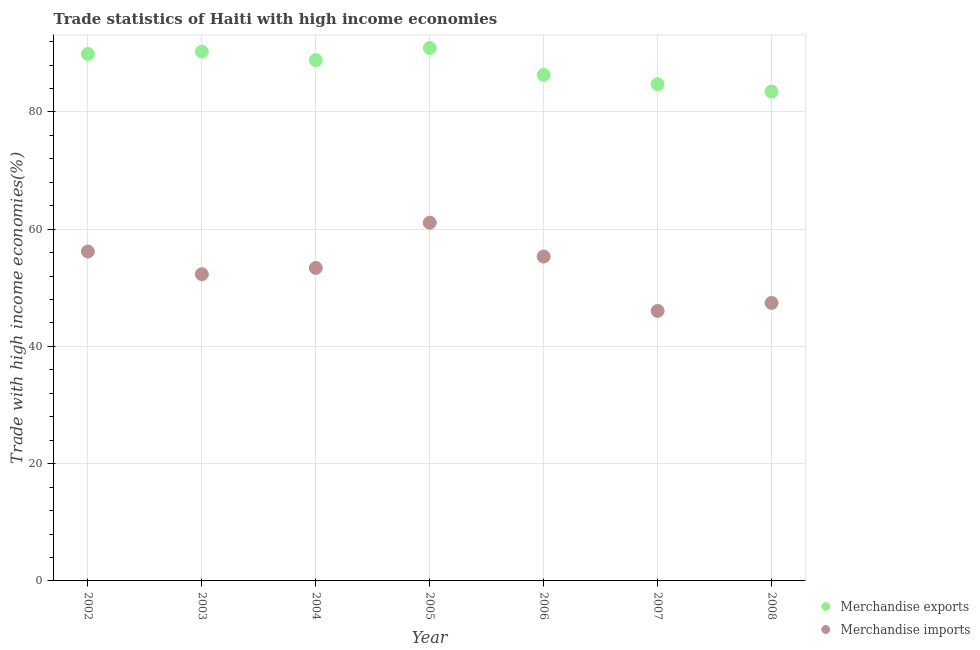Is the number of dotlines equal to the number of legend labels?
Offer a very short reply. Yes. What is the merchandise imports in 2003?
Provide a succinct answer. 52.32. Across all years, what is the maximum merchandise exports?
Offer a very short reply. 90.91. Across all years, what is the minimum merchandise exports?
Provide a short and direct response. 83.47. In which year was the merchandise exports maximum?
Provide a short and direct response. 2005. In which year was the merchandise exports minimum?
Offer a terse response. 2008. What is the total merchandise imports in the graph?
Keep it short and to the point. 371.85. What is the difference between the merchandise imports in 2003 and that in 2008?
Make the answer very short. 4.9. What is the difference between the merchandise imports in 2006 and the merchandise exports in 2002?
Your response must be concise. -34.56. What is the average merchandise exports per year?
Provide a succinct answer. 87.79. In the year 2003, what is the difference between the merchandise imports and merchandise exports?
Provide a short and direct response. -37.97. In how many years, is the merchandise imports greater than 64 %?
Provide a short and direct response. 0. What is the ratio of the merchandise imports in 2002 to that in 2007?
Provide a succinct answer. 1.22. What is the difference between the highest and the second highest merchandise exports?
Keep it short and to the point. 0.61. What is the difference between the highest and the lowest merchandise exports?
Keep it short and to the point. 7.44. Is the sum of the merchandise imports in 2002 and 2004 greater than the maximum merchandise exports across all years?
Ensure brevity in your answer.  Yes. Does the merchandise exports monotonically increase over the years?
Make the answer very short. No. Is the merchandise exports strictly less than the merchandise imports over the years?
Offer a very short reply. No. What is the difference between two consecutive major ticks on the Y-axis?
Offer a terse response. 20. What is the title of the graph?
Your response must be concise. Trade statistics of Haiti with high income economies. What is the label or title of the X-axis?
Give a very brief answer. Year. What is the label or title of the Y-axis?
Give a very brief answer. Trade with high income economies(%). What is the Trade with high income economies(%) of Merchandise exports in 2002?
Ensure brevity in your answer.  89.89. What is the Trade with high income economies(%) of Merchandise imports in 2002?
Your answer should be very brief. 56.19. What is the Trade with high income economies(%) in Merchandise exports in 2003?
Your answer should be compact. 90.3. What is the Trade with high income economies(%) of Merchandise imports in 2003?
Keep it short and to the point. 52.32. What is the Trade with high income economies(%) of Merchandise exports in 2004?
Your response must be concise. 88.85. What is the Trade with high income economies(%) of Merchandise imports in 2004?
Give a very brief answer. 53.39. What is the Trade with high income economies(%) in Merchandise exports in 2005?
Offer a terse response. 90.91. What is the Trade with high income economies(%) of Merchandise imports in 2005?
Offer a very short reply. 61.12. What is the Trade with high income economies(%) in Merchandise exports in 2006?
Your response must be concise. 86.34. What is the Trade with high income economies(%) in Merchandise imports in 2006?
Your answer should be very brief. 55.34. What is the Trade with high income economies(%) of Merchandise exports in 2007?
Make the answer very short. 84.73. What is the Trade with high income economies(%) in Merchandise imports in 2007?
Keep it short and to the point. 46.06. What is the Trade with high income economies(%) in Merchandise exports in 2008?
Your response must be concise. 83.47. What is the Trade with high income economies(%) in Merchandise imports in 2008?
Provide a succinct answer. 47.43. Across all years, what is the maximum Trade with high income economies(%) in Merchandise exports?
Make the answer very short. 90.91. Across all years, what is the maximum Trade with high income economies(%) in Merchandise imports?
Ensure brevity in your answer.  61.12. Across all years, what is the minimum Trade with high income economies(%) of Merchandise exports?
Offer a very short reply. 83.47. Across all years, what is the minimum Trade with high income economies(%) of Merchandise imports?
Offer a terse response. 46.06. What is the total Trade with high income economies(%) in Merchandise exports in the graph?
Your answer should be compact. 614.5. What is the total Trade with high income economies(%) of Merchandise imports in the graph?
Make the answer very short. 371.85. What is the difference between the Trade with high income economies(%) of Merchandise exports in 2002 and that in 2003?
Your answer should be compact. -0.4. What is the difference between the Trade with high income economies(%) in Merchandise imports in 2002 and that in 2003?
Give a very brief answer. 3.87. What is the difference between the Trade with high income economies(%) in Merchandise exports in 2002 and that in 2004?
Keep it short and to the point. 1.04. What is the difference between the Trade with high income economies(%) in Merchandise imports in 2002 and that in 2004?
Keep it short and to the point. 2.8. What is the difference between the Trade with high income economies(%) in Merchandise exports in 2002 and that in 2005?
Ensure brevity in your answer.  -1.01. What is the difference between the Trade with high income economies(%) in Merchandise imports in 2002 and that in 2005?
Your answer should be very brief. -4.92. What is the difference between the Trade with high income economies(%) in Merchandise exports in 2002 and that in 2006?
Provide a succinct answer. 3.56. What is the difference between the Trade with high income economies(%) of Merchandise imports in 2002 and that in 2006?
Give a very brief answer. 0.86. What is the difference between the Trade with high income economies(%) in Merchandise exports in 2002 and that in 2007?
Your answer should be compact. 5.16. What is the difference between the Trade with high income economies(%) of Merchandise imports in 2002 and that in 2007?
Make the answer very short. 10.13. What is the difference between the Trade with high income economies(%) of Merchandise exports in 2002 and that in 2008?
Keep it short and to the point. 6.42. What is the difference between the Trade with high income economies(%) in Merchandise imports in 2002 and that in 2008?
Make the answer very short. 8.77. What is the difference between the Trade with high income economies(%) of Merchandise exports in 2003 and that in 2004?
Give a very brief answer. 1.45. What is the difference between the Trade with high income economies(%) of Merchandise imports in 2003 and that in 2004?
Offer a very short reply. -1.07. What is the difference between the Trade with high income economies(%) in Merchandise exports in 2003 and that in 2005?
Make the answer very short. -0.61. What is the difference between the Trade with high income economies(%) in Merchandise imports in 2003 and that in 2005?
Provide a succinct answer. -8.79. What is the difference between the Trade with high income economies(%) of Merchandise exports in 2003 and that in 2006?
Make the answer very short. 3.96. What is the difference between the Trade with high income economies(%) in Merchandise imports in 2003 and that in 2006?
Give a very brief answer. -3.01. What is the difference between the Trade with high income economies(%) in Merchandise exports in 2003 and that in 2007?
Provide a short and direct response. 5.56. What is the difference between the Trade with high income economies(%) of Merchandise imports in 2003 and that in 2007?
Your answer should be compact. 6.26. What is the difference between the Trade with high income economies(%) of Merchandise exports in 2003 and that in 2008?
Provide a succinct answer. 6.83. What is the difference between the Trade with high income economies(%) in Merchandise imports in 2003 and that in 2008?
Give a very brief answer. 4.9. What is the difference between the Trade with high income economies(%) of Merchandise exports in 2004 and that in 2005?
Ensure brevity in your answer.  -2.06. What is the difference between the Trade with high income economies(%) in Merchandise imports in 2004 and that in 2005?
Offer a very short reply. -7.72. What is the difference between the Trade with high income economies(%) in Merchandise exports in 2004 and that in 2006?
Provide a succinct answer. 2.51. What is the difference between the Trade with high income economies(%) of Merchandise imports in 2004 and that in 2006?
Your answer should be very brief. -1.94. What is the difference between the Trade with high income economies(%) in Merchandise exports in 2004 and that in 2007?
Give a very brief answer. 4.12. What is the difference between the Trade with high income economies(%) of Merchandise imports in 2004 and that in 2007?
Your response must be concise. 7.33. What is the difference between the Trade with high income economies(%) of Merchandise exports in 2004 and that in 2008?
Offer a terse response. 5.38. What is the difference between the Trade with high income economies(%) in Merchandise imports in 2004 and that in 2008?
Ensure brevity in your answer.  5.97. What is the difference between the Trade with high income economies(%) in Merchandise exports in 2005 and that in 2006?
Provide a succinct answer. 4.57. What is the difference between the Trade with high income economies(%) of Merchandise imports in 2005 and that in 2006?
Offer a terse response. 5.78. What is the difference between the Trade with high income economies(%) of Merchandise exports in 2005 and that in 2007?
Keep it short and to the point. 6.17. What is the difference between the Trade with high income economies(%) in Merchandise imports in 2005 and that in 2007?
Give a very brief answer. 15.05. What is the difference between the Trade with high income economies(%) in Merchandise exports in 2005 and that in 2008?
Keep it short and to the point. 7.44. What is the difference between the Trade with high income economies(%) in Merchandise imports in 2005 and that in 2008?
Your answer should be compact. 13.69. What is the difference between the Trade with high income economies(%) of Merchandise exports in 2006 and that in 2007?
Ensure brevity in your answer.  1.6. What is the difference between the Trade with high income economies(%) in Merchandise imports in 2006 and that in 2007?
Provide a short and direct response. 9.28. What is the difference between the Trade with high income economies(%) in Merchandise exports in 2006 and that in 2008?
Give a very brief answer. 2.87. What is the difference between the Trade with high income economies(%) in Merchandise imports in 2006 and that in 2008?
Give a very brief answer. 7.91. What is the difference between the Trade with high income economies(%) in Merchandise exports in 2007 and that in 2008?
Ensure brevity in your answer.  1.26. What is the difference between the Trade with high income economies(%) in Merchandise imports in 2007 and that in 2008?
Offer a terse response. -1.36. What is the difference between the Trade with high income economies(%) of Merchandise exports in 2002 and the Trade with high income economies(%) of Merchandise imports in 2003?
Ensure brevity in your answer.  37.57. What is the difference between the Trade with high income economies(%) in Merchandise exports in 2002 and the Trade with high income economies(%) in Merchandise imports in 2004?
Keep it short and to the point. 36.5. What is the difference between the Trade with high income economies(%) in Merchandise exports in 2002 and the Trade with high income economies(%) in Merchandise imports in 2005?
Offer a terse response. 28.78. What is the difference between the Trade with high income economies(%) in Merchandise exports in 2002 and the Trade with high income economies(%) in Merchandise imports in 2006?
Your answer should be compact. 34.56. What is the difference between the Trade with high income economies(%) of Merchandise exports in 2002 and the Trade with high income economies(%) of Merchandise imports in 2007?
Your answer should be very brief. 43.83. What is the difference between the Trade with high income economies(%) in Merchandise exports in 2002 and the Trade with high income economies(%) in Merchandise imports in 2008?
Provide a succinct answer. 42.47. What is the difference between the Trade with high income economies(%) of Merchandise exports in 2003 and the Trade with high income economies(%) of Merchandise imports in 2004?
Ensure brevity in your answer.  36.9. What is the difference between the Trade with high income economies(%) of Merchandise exports in 2003 and the Trade with high income economies(%) of Merchandise imports in 2005?
Provide a short and direct response. 29.18. What is the difference between the Trade with high income economies(%) of Merchandise exports in 2003 and the Trade with high income economies(%) of Merchandise imports in 2006?
Give a very brief answer. 34.96. What is the difference between the Trade with high income economies(%) of Merchandise exports in 2003 and the Trade with high income economies(%) of Merchandise imports in 2007?
Keep it short and to the point. 44.24. What is the difference between the Trade with high income economies(%) of Merchandise exports in 2003 and the Trade with high income economies(%) of Merchandise imports in 2008?
Offer a terse response. 42.87. What is the difference between the Trade with high income economies(%) in Merchandise exports in 2004 and the Trade with high income economies(%) in Merchandise imports in 2005?
Give a very brief answer. 27.74. What is the difference between the Trade with high income economies(%) of Merchandise exports in 2004 and the Trade with high income economies(%) of Merchandise imports in 2006?
Provide a succinct answer. 33.51. What is the difference between the Trade with high income economies(%) of Merchandise exports in 2004 and the Trade with high income economies(%) of Merchandise imports in 2007?
Your response must be concise. 42.79. What is the difference between the Trade with high income economies(%) of Merchandise exports in 2004 and the Trade with high income economies(%) of Merchandise imports in 2008?
Offer a terse response. 41.43. What is the difference between the Trade with high income economies(%) of Merchandise exports in 2005 and the Trade with high income economies(%) of Merchandise imports in 2006?
Keep it short and to the point. 35.57. What is the difference between the Trade with high income economies(%) in Merchandise exports in 2005 and the Trade with high income economies(%) in Merchandise imports in 2007?
Provide a succinct answer. 44.85. What is the difference between the Trade with high income economies(%) of Merchandise exports in 2005 and the Trade with high income economies(%) of Merchandise imports in 2008?
Provide a short and direct response. 43.48. What is the difference between the Trade with high income economies(%) in Merchandise exports in 2006 and the Trade with high income economies(%) in Merchandise imports in 2007?
Give a very brief answer. 40.28. What is the difference between the Trade with high income economies(%) in Merchandise exports in 2006 and the Trade with high income economies(%) in Merchandise imports in 2008?
Make the answer very short. 38.91. What is the difference between the Trade with high income economies(%) in Merchandise exports in 2007 and the Trade with high income economies(%) in Merchandise imports in 2008?
Your answer should be compact. 37.31. What is the average Trade with high income economies(%) in Merchandise exports per year?
Your answer should be compact. 87.79. What is the average Trade with high income economies(%) in Merchandise imports per year?
Give a very brief answer. 53.12. In the year 2002, what is the difference between the Trade with high income economies(%) of Merchandise exports and Trade with high income economies(%) of Merchandise imports?
Your answer should be very brief. 33.7. In the year 2003, what is the difference between the Trade with high income economies(%) of Merchandise exports and Trade with high income economies(%) of Merchandise imports?
Provide a short and direct response. 37.97. In the year 2004, what is the difference between the Trade with high income economies(%) in Merchandise exports and Trade with high income economies(%) in Merchandise imports?
Your response must be concise. 35.46. In the year 2005, what is the difference between the Trade with high income economies(%) in Merchandise exports and Trade with high income economies(%) in Merchandise imports?
Your answer should be compact. 29.79. In the year 2006, what is the difference between the Trade with high income economies(%) in Merchandise exports and Trade with high income economies(%) in Merchandise imports?
Ensure brevity in your answer.  31. In the year 2007, what is the difference between the Trade with high income economies(%) in Merchandise exports and Trade with high income economies(%) in Merchandise imports?
Your response must be concise. 38.67. In the year 2008, what is the difference between the Trade with high income economies(%) of Merchandise exports and Trade with high income economies(%) of Merchandise imports?
Offer a terse response. 36.05. What is the ratio of the Trade with high income economies(%) in Merchandise exports in 2002 to that in 2003?
Offer a terse response. 1. What is the ratio of the Trade with high income economies(%) of Merchandise imports in 2002 to that in 2003?
Your answer should be compact. 1.07. What is the ratio of the Trade with high income economies(%) of Merchandise exports in 2002 to that in 2004?
Provide a short and direct response. 1.01. What is the ratio of the Trade with high income economies(%) in Merchandise imports in 2002 to that in 2004?
Give a very brief answer. 1.05. What is the ratio of the Trade with high income economies(%) in Merchandise imports in 2002 to that in 2005?
Provide a short and direct response. 0.92. What is the ratio of the Trade with high income economies(%) in Merchandise exports in 2002 to that in 2006?
Keep it short and to the point. 1.04. What is the ratio of the Trade with high income economies(%) in Merchandise imports in 2002 to that in 2006?
Provide a short and direct response. 1.02. What is the ratio of the Trade with high income economies(%) of Merchandise exports in 2002 to that in 2007?
Offer a very short reply. 1.06. What is the ratio of the Trade with high income economies(%) of Merchandise imports in 2002 to that in 2007?
Keep it short and to the point. 1.22. What is the ratio of the Trade with high income economies(%) of Merchandise exports in 2002 to that in 2008?
Make the answer very short. 1.08. What is the ratio of the Trade with high income economies(%) of Merchandise imports in 2002 to that in 2008?
Provide a succinct answer. 1.18. What is the ratio of the Trade with high income economies(%) in Merchandise exports in 2003 to that in 2004?
Provide a short and direct response. 1.02. What is the ratio of the Trade with high income economies(%) in Merchandise exports in 2003 to that in 2005?
Your answer should be very brief. 0.99. What is the ratio of the Trade with high income economies(%) of Merchandise imports in 2003 to that in 2005?
Your answer should be compact. 0.86. What is the ratio of the Trade with high income economies(%) of Merchandise exports in 2003 to that in 2006?
Offer a very short reply. 1.05. What is the ratio of the Trade with high income economies(%) in Merchandise imports in 2003 to that in 2006?
Provide a short and direct response. 0.95. What is the ratio of the Trade with high income economies(%) of Merchandise exports in 2003 to that in 2007?
Offer a very short reply. 1.07. What is the ratio of the Trade with high income economies(%) in Merchandise imports in 2003 to that in 2007?
Provide a short and direct response. 1.14. What is the ratio of the Trade with high income economies(%) of Merchandise exports in 2003 to that in 2008?
Your answer should be very brief. 1.08. What is the ratio of the Trade with high income economies(%) of Merchandise imports in 2003 to that in 2008?
Offer a very short reply. 1.1. What is the ratio of the Trade with high income economies(%) in Merchandise exports in 2004 to that in 2005?
Keep it short and to the point. 0.98. What is the ratio of the Trade with high income economies(%) of Merchandise imports in 2004 to that in 2005?
Keep it short and to the point. 0.87. What is the ratio of the Trade with high income economies(%) of Merchandise exports in 2004 to that in 2006?
Keep it short and to the point. 1.03. What is the ratio of the Trade with high income economies(%) in Merchandise imports in 2004 to that in 2006?
Provide a short and direct response. 0.96. What is the ratio of the Trade with high income economies(%) in Merchandise exports in 2004 to that in 2007?
Provide a succinct answer. 1.05. What is the ratio of the Trade with high income economies(%) in Merchandise imports in 2004 to that in 2007?
Your answer should be compact. 1.16. What is the ratio of the Trade with high income economies(%) of Merchandise exports in 2004 to that in 2008?
Your answer should be compact. 1.06. What is the ratio of the Trade with high income economies(%) of Merchandise imports in 2004 to that in 2008?
Give a very brief answer. 1.13. What is the ratio of the Trade with high income economies(%) in Merchandise exports in 2005 to that in 2006?
Give a very brief answer. 1.05. What is the ratio of the Trade with high income economies(%) in Merchandise imports in 2005 to that in 2006?
Make the answer very short. 1.1. What is the ratio of the Trade with high income economies(%) in Merchandise exports in 2005 to that in 2007?
Provide a short and direct response. 1.07. What is the ratio of the Trade with high income economies(%) in Merchandise imports in 2005 to that in 2007?
Your answer should be compact. 1.33. What is the ratio of the Trade with high income economies(%) in Merchandise exports in 2005 to that in 2008?
Keep it short and to the point. 1.09. What is the ratio of the Trade with high income economies(%) in Merchandise imports in 2005 to that in 2008?
Make the answer very short. 1.29. What is the ratio of the Trade with high income economies(%) of Merchandise exports in 2006 to that in 2007?
Your answer should be very brief. 1.02. What is the ratio of the Trade with high income economies(%) in Merchandise imports in 2006 to that in 2007?
Ensure brevity in your answer.  1.2. What is the ratio of the Trade with high income economies(%) of Merchandise exports in 2006 to that in 2008?
Your answer should be very brief. 1.03. What is the ratio of the Trade with high income economies(%) in Merchandise imports in 2006 to that in 2008?
Your answer should be very brief. 1.17. What is the ratio of the Trade with high income economies(%) in Merchandise exports in 2007 to that in 2008?
Provide a short and direct response. 1.02. What is the ratio of the Trade with high income economies(%) in Merchandise imports in 2007 to that in 2008?
Provide a short and direct response. 0.97. What is the difference between the highest and the second highest Trade with high income economies(%) of Merchandise exports?
Keep it short and to the point. 0.61. What is the difference between the highest and the second highest Trade with high income economies(%) of Merchandise imports?
Keep it short and to the point. 4.92. What is the difference between the highest and the lowest Trade with high income economies(%) in Merchandise exports?
Your response must be concise. 7.44. What is the difference between the highest and the lowest Trade with high income economies(%) in Merchandise imports?
Keep it short and to the point. 15.05. 